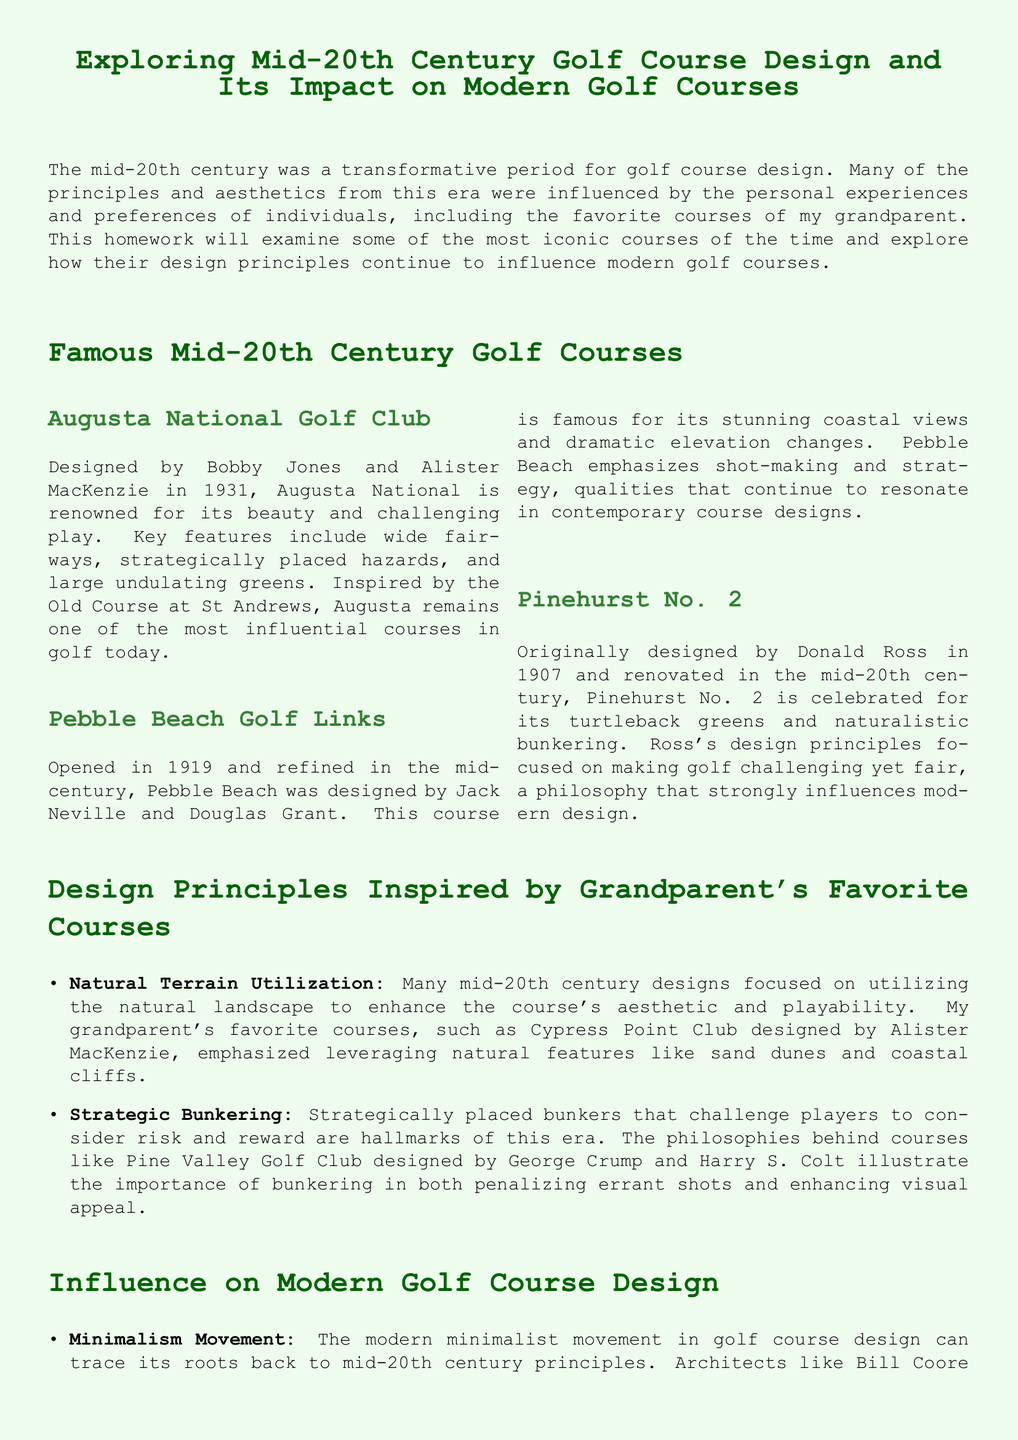What year was Augusta National Golf Club designed? The document states that Augusta National was designed in 1931.
Answer: 1931 Who were the designers of Pebble Beach Golf Links? The document identifies Jack Neville and Douglas Grant as the designers of Pebble Beach Golf Links.
Answer: Jack Neville and Douglas Grant What is a key feature of Pinehurst No. 2 mentioned in the document? The document highlights turtleback greens as a key feature of Pinehurst No. 2.
Answer: Turtleback greens Which principle emphasizes using the natural landscape in golf course design? The principle mentioned in the document is Natural Terrain Utilization, which underscores leveraging the natural landscape.
Answer: Natural Terrain Utilization How did mid-20th century designs influence modern sustainable practices? The document explains that natural terrain and strategic landscaping from mid-20th century designs inform today's sustainable practices.
Answer: Sustainable practices What is the minimalist movement in modern golf course design inspired by? The document states that the minimalist movement is inspired by mid-20th century principles.
Answer: Mid-20th century principles Which course is cited as an example of strategic bunkering? The document refers to Pine Valley Golf Club as an example of strategic bunkering.
Answer: Pine Valley Golf Club What is the conclusion about the mid-20th century's impact on modern golf? The document concludes that principles from the mid-20th century shape modern golf course design.
Answer: Shape modern golf course design 